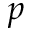<formula> <loc_0><loc_0><loc_500><loc_500>_ { p }</formula> 